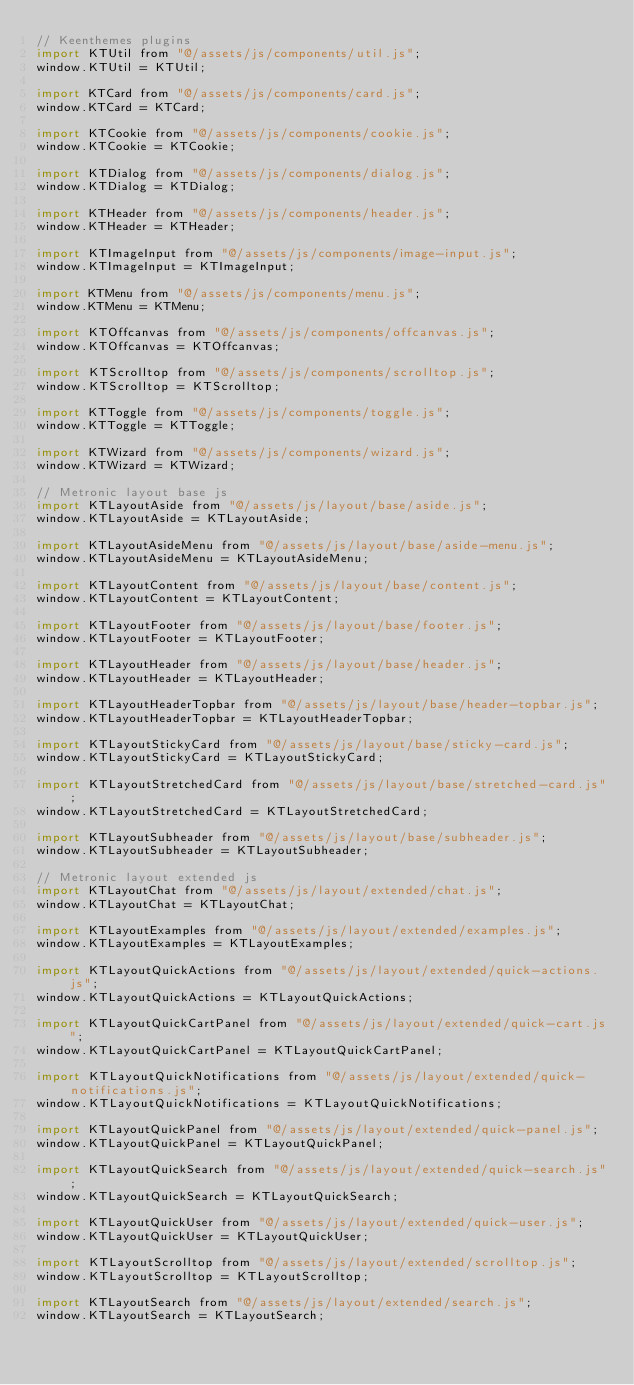<code> <loc_0><loc_0><loc_500><loc_500><_JavaScript_>// Keenthemes plugins
import KTUtil from "@/assets/js/components/util.js";
window.KTUtil = KTUtil;

import KTCard from "@/assets/js/components/card.js";
window.KTCard = KTCard;

import KTCookie from "@/assets/js/components/cookie.js";
window.KTCookie = KTCookie;

import KTDialog from "@/assets/js/components/dialog.js";
window.KTDialog = KTDialog;

import KTHeader from "@/assets/js/components/header.js";
window.KTHeader = KTHeader;

import KTImageInput from "@/assets/js/components/image-input.js";
window.KTImageInput = KTImageInput;

import KTMenu from "@/assets/js/components/menu.js";
window.KTMenu = KTMenu;

import KTOffcanvas from "@/assets/js/components/offcanvas.js";
window.KTOffcanvas = KTOffcanvas;

import KTScrolltop from "@/assets/js/components/scrolltop.js";
window.KTScrolltop = KTScrolltop;

import KTToggle from "@/assets/js/components/toggle.js";
window.KTToggle = KTToggle;

import KTWizard from "@/assets/js/components/wizard.js";
window.KTWizard = KTWizard;

// Metronic layout base js
import KTLayoutAside from "@/assets/js/layout/base/aside.js";
window.KTLayoutAside = KTLayoutAside;

import KTLayoutAsideMenu from "@/assets/js/layout/base/aside-menu.js";
window.KTLayoutAsideMenu = KTLayoutAsideMenu;

import KTLayoutContent from "@/assets/js/layout/base/content.js";
window.KTLayoutContent = KTLayoutContent;

import KTLayoutFooter from "@/assets/js/layout/base/footer.js";
window.KTLayoutFooter = KTLayoutFooter;

import KTLayoutHeader from "@/assets/js/layout/base/header.js";
window.KTLayoutHeader = KTLayoutHeader;

import KTLayoutHeaderTopbar from "@/assets/js/layout/base/header-topbar.js";
window.KTLayoutHeaderTopbar = KTLayoutHeaderTopbar;

import KTLayoutStickyCard from "@/assets/js/layout/base/sticky-card.js";
window.KTLayoutStickyCard = KTLayoutStickyCard;

import KTLayoutStretchedCard from "@/assets/js/layout/base/stretched-card.js";
window.KTLayoutStretchedCard = KTLayoutStretchedCard;

import KTLayoutSubheader from "@/assets/js/layout/base/subheader.js";
window.KTLayoutSubheader = KTLayoutSubheader;

// Metronic layout extended js
import KTLayoutChat from "@/assets/js/layout/extended/chat.js";
window.KTLayoutChat = KTLayoutChat;

import KTLayoutExamples from "@/assets/js/layout/extended/examples.js";
window.KTLayoutExamples = KTLayoutExamples;

import KTLayoutQuickActions from "@/assets/js/layout/extended/quick-actions.js";
window.KTLayoutQuickActions = KTLayoutQuickActions;

import KTLayoutQuickCartPanel from "@/assets/js/layout/extended/quick-cart.js";
window.KTLayoutQuickCartPanel = KTLayoutQuickCartPanel;

import KTLayoutQuickNotifications from "@/assets/js/layout/extended/quick-notifications.js";
window.KTLayoutQuickNotifications = KTLayoutQuickNotifications;

import KTLayoutQuickPanel from "@/assets/js/layout/extended/quick-panel.js";
window.KTLayoutQuickPanel = KTLayoutQuickPanel;

import KTLayoutQuickSearch from "@/assets/js/layout/extended/quick-search.js";
window.KTLayoutQuickSearch = KTLayoutQuickSearch;

import KTLayoutQuickUser from "@/assets/js/layout/extended/quick-user.js";
window.KTLayoutQuickUser = KTLayoutQuickUser;

import KTLayoutScrolltop from "@/assets/js/layout/extended/scrolltop.js";
window.KTLayoutScrolltop = KTLayoutScrolltop;

import KTLayoutSearch from "@/assets/js/layout/extended/search.js";
window.KTLayoutSearch = KTLayoutSearch;
</code> 